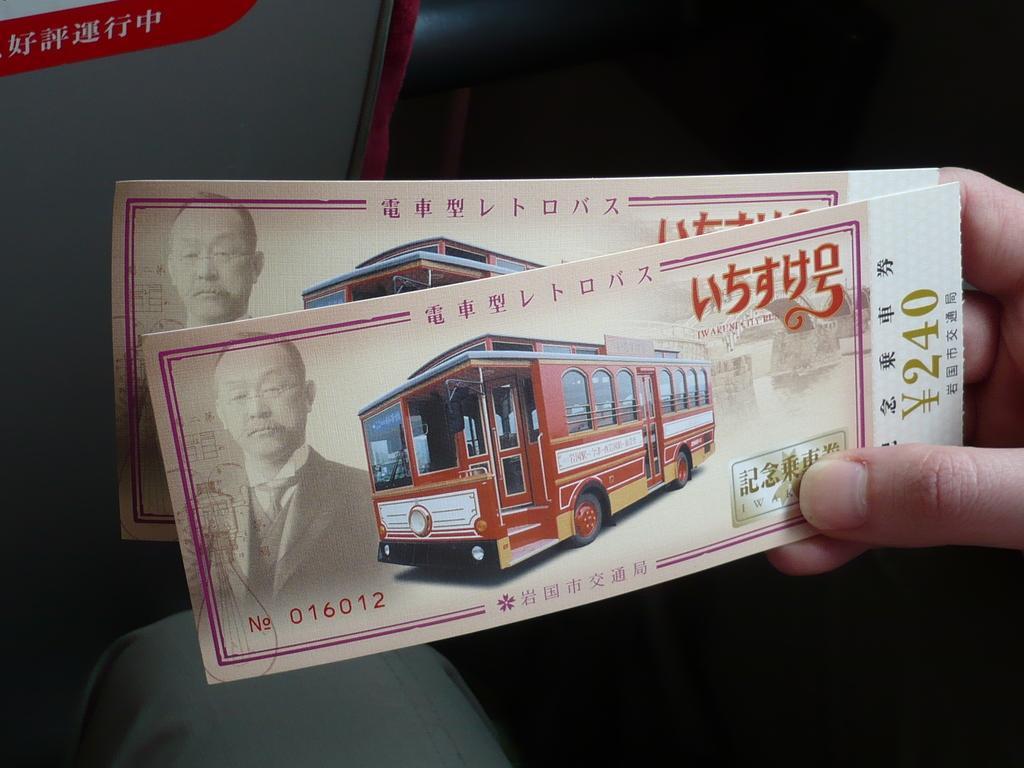Could you give a brief overview of what you see in this image? In this image I can see the person holding the papers. On the papers I can see the vehicle, person and something is written. I can see the red, grey and black background. 